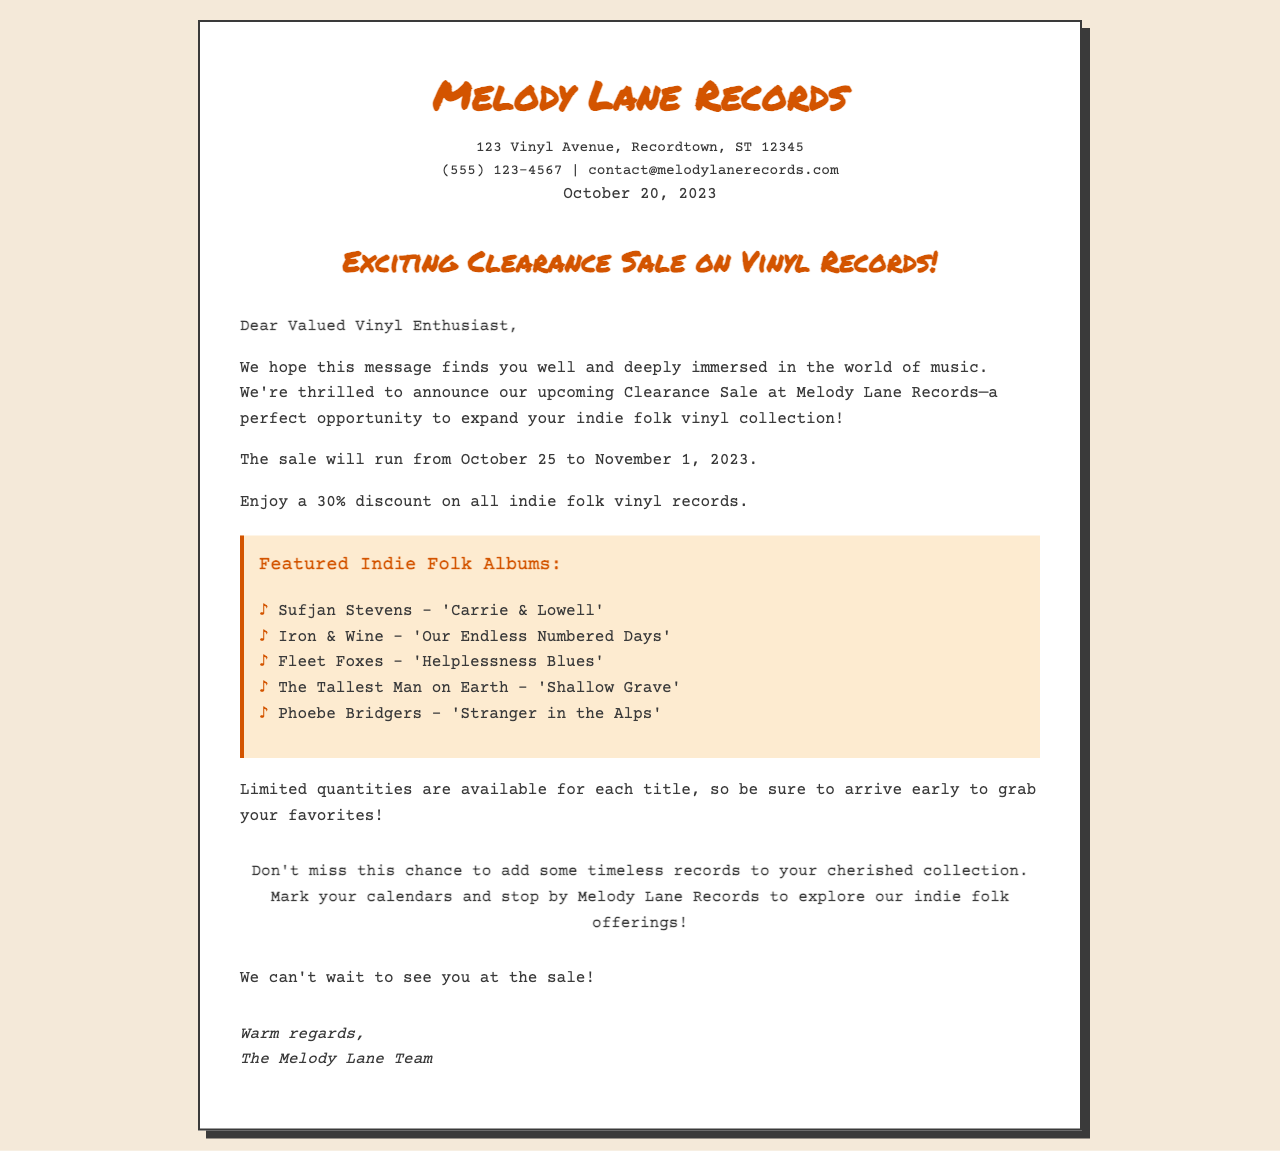What is the store's name? The store's name is mentioned in the heading and throughout the document.
Answer: Melody Lane Records What is the discount percentage on indie folk vinyl records? The document states the specific discount offered during the sale.
Answer: 30% When does the clearance sale start? The document mentions the start date of the sale clearly.
Answer: October 25, 2023 Name one featured album in the sale. The document lists several titles of indie folk albums featured in the sale.
Answer: 'Carrie & Lowell' What is the end date of the clearance sale? The document specifies the end date of the sale.
Answer: November 1, 2023 How many notable albums are mentioned in the document? The document lists a specific number of notable albums being featured in the sale.
Answer: Five What should customers do to secure their favorites? The document advises on what action customers should take regarding the availability of others' favorites.
Answer: Arrive early Who is the letter signed by? The signature line at the end of the letter indicates who it is from.
Answer: The Melody Lane Team What is the location of the store? The document provides the physical address of Melody Lane Records.
Answer: 123 Vinyl Avenue, Recordtown, ST 12345 